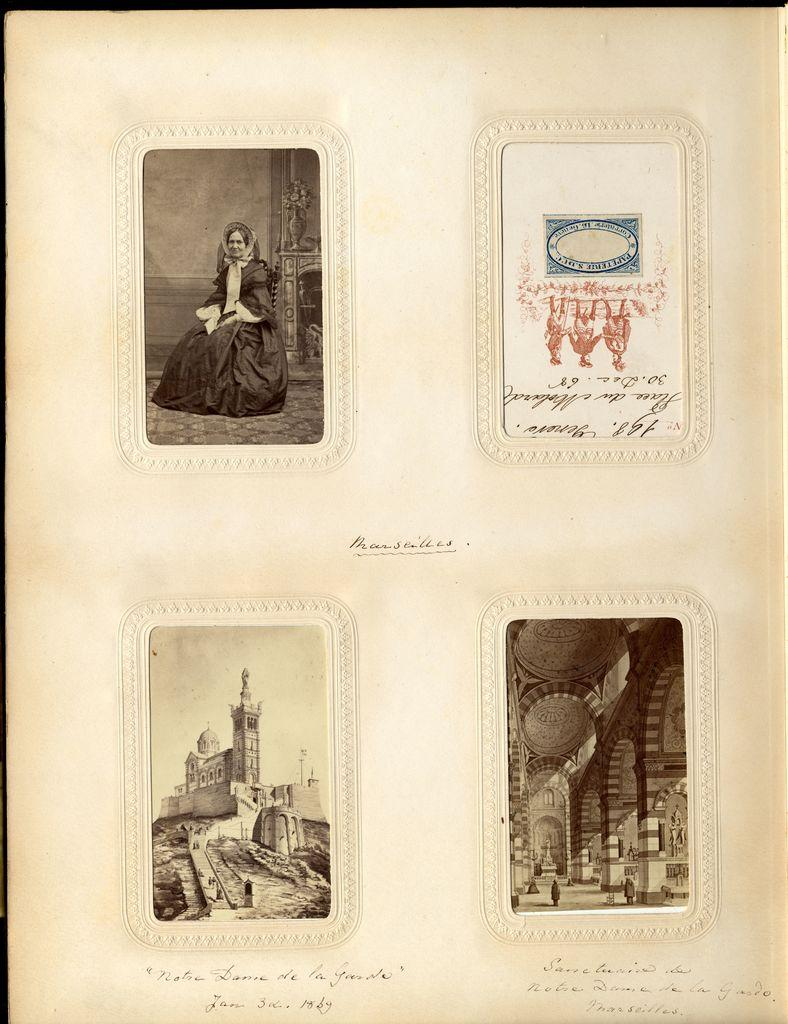What is on the paper in the image? There are images on the paper. Can you describe the images on the paper? A woman is depicted at the top of the paper, and a fort is depicted at the bottom of the paper. What type of pest can be seen crawling on the woman's image in the picture? There are no pests visible in the image; it only features the woman and the fort. 